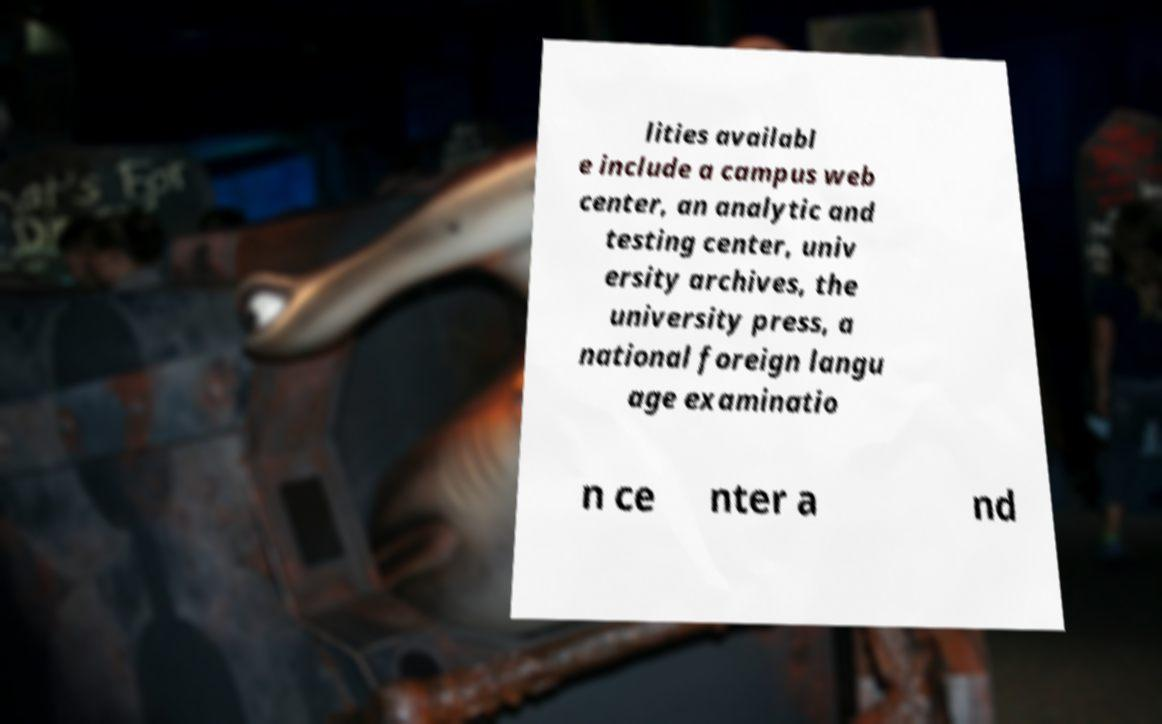Could you extract and type out the text from this image? lities availabl e include a campus web center, an analytic and testing center, univ ersity archives, the university press, a national foreign langu age examinatio n ce nter a nd 